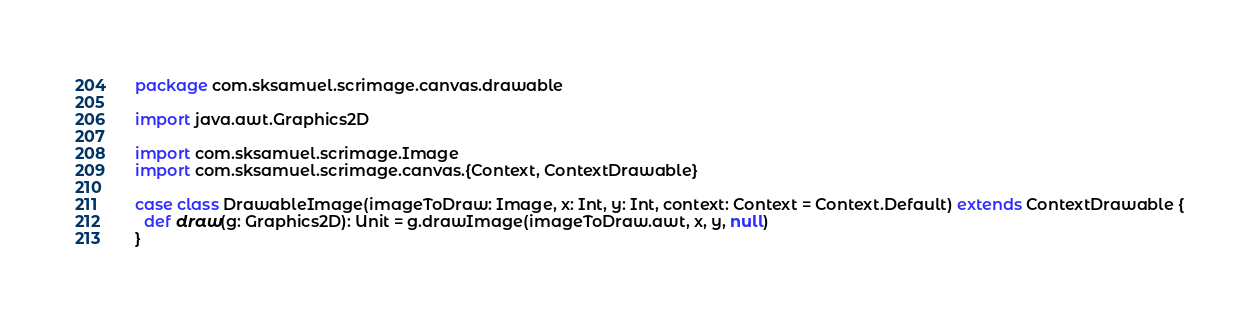<code> <loc_0><loc_0><loc_500><loc_500><_Scala_>package com.sksamuel.scrimage.canvas.drawable

import java.awt.Graphics2D

import com.sksamuel.scrimage.Image
import com.sksamuel.scrimage.canvas.{Context, ContextDrawable}

case class DrawableImage(imageToDraw: Image, x: Int, y: Int, context: Context = Context.Default) extends ContextDrawable {
  def draw(g: Graphics2D): Unit = g.drawImage(imageToDraw.awt, x, y, null)
}
</code> 